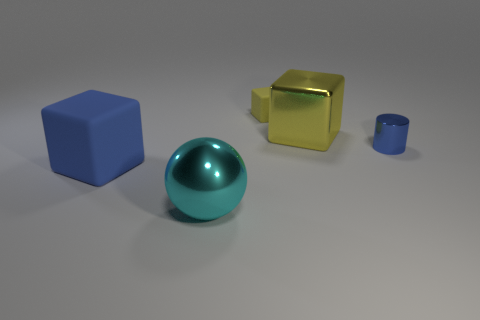What could be the function of these objects? These objects resemble geometric shapes commonly used as reference items in visual arts or 3D modeling to showcase texture, color, and lighting effects. They do not appear to have a specific function beyond demonstration or educational purposes. Could they have any practical use? While these particular objects seem to be more demonstrative, similar shapes could be used in various practical contexts, such as children's building blocks, elements in design or decoration, or even as educational tools for teaching geometry. 